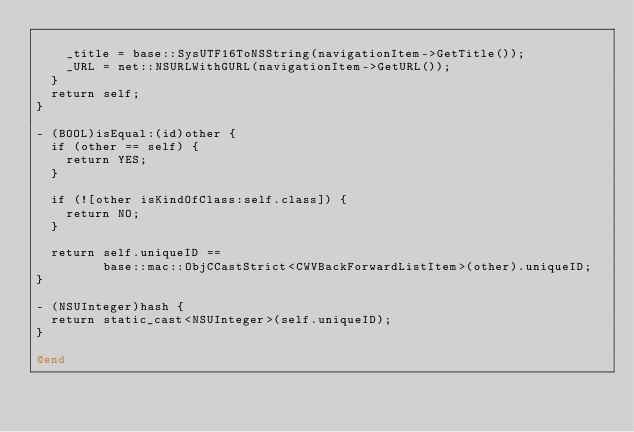<code> <loc_0><loc_0><loc_500><loc_500><_ObjectiveC_>
    _title = base::SysUTF16ToNSString(navigationItem->GetTitle());
    _URL = net::NSURLWithGURL(navigationItem->GetURL());
  }
  return self;
}

- (BOOL)isEqual:(id)other {
  if (other == self) {
    return YES;
  }

  if (![other isKindOfClass:self.class]) {
    return NO;
  }

  return self.uniqueID ==
         base::mac::ObjCCastStrict<CWVBackForwardListItem>(other).uniqueID;
}

- (NSUInteger)hash {
  return static_cast<NSUInteger>(self.uniqueID);
}

@end
</code> 